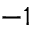<formula> <loc_0><loc_0><loc_500><loc_500>^ { - 1 }</formula> 